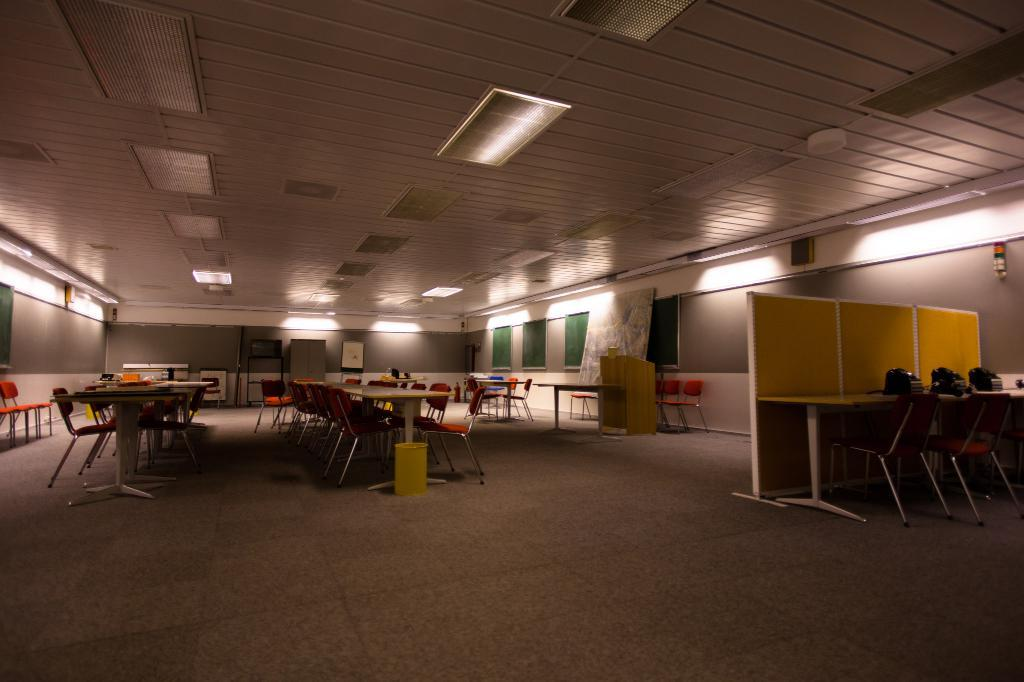What type of furniture is present in the image? There is a table, chairs, and a desk in the image. What other objects can be seen in the image? There is a dustbin, cabins, telephones, boards, and lights in the image. What is the background of the image? There is a wall in the background of the image. How many men are visible in the image? There are no men present in the image. What is the angle of the desk in the image? The angle of the desk cannot be determined from the image, as it is not shown from an angle that would allow us to see its orientation. 